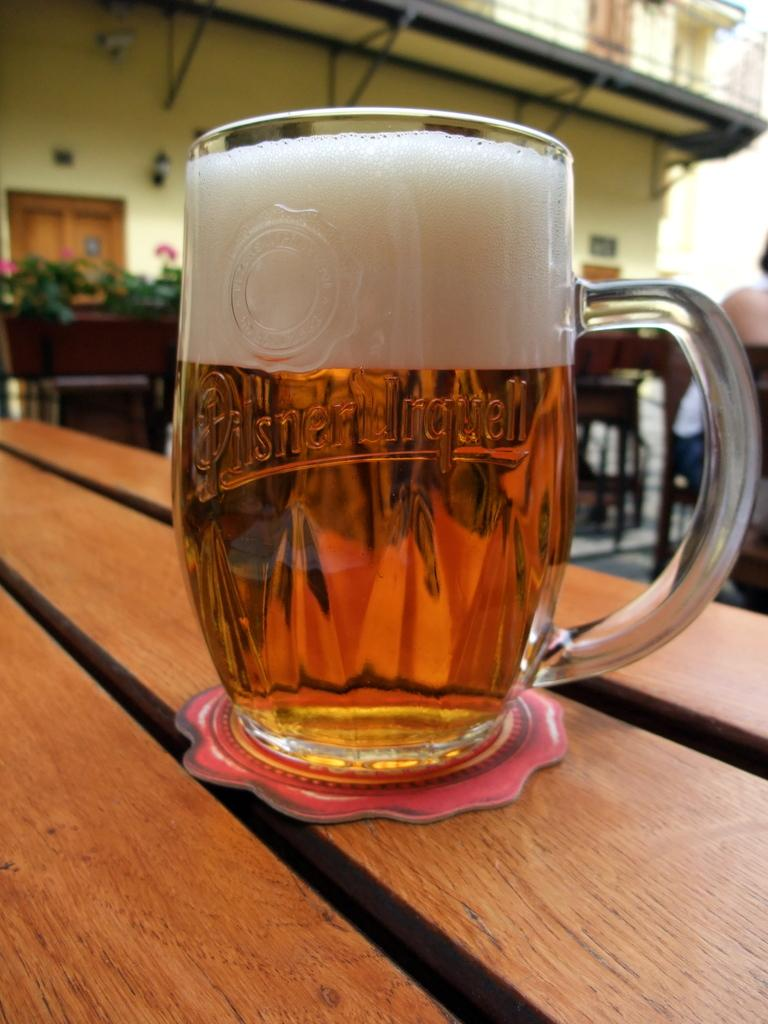What is on the wooden table in the image? There is a glass with a beer on a wooden table. What can be seen in the background of the image? There is a building with doors in the background. What type of vegetation is present in the image? There are plants in pots in the front of the image. What type of balls are being used for the game in the image? There is no game or balls present in the image. 